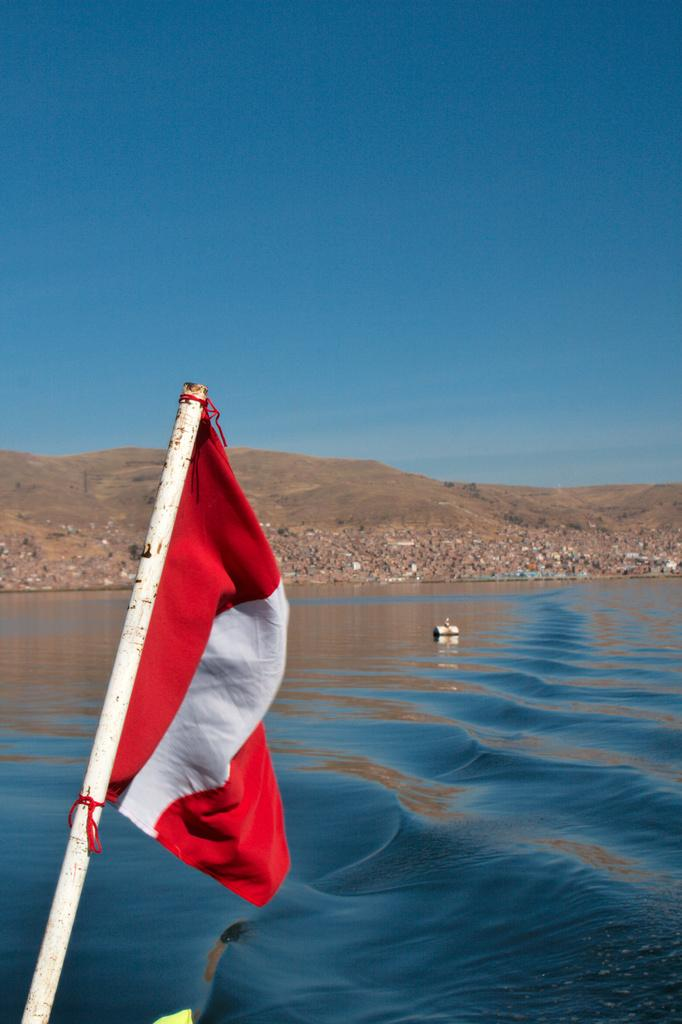What is located on the left side of the image? There is a flag on the left side of the image. What can be seen in the center of the image? There is water in the center of the image. How many beans are floating in the water in the image? There are no beans present in the image; it features a flag on the left side and water in the center. What type of balance is depicted in the image? There is no balance depicted in the image; it only shows a flag and water. 